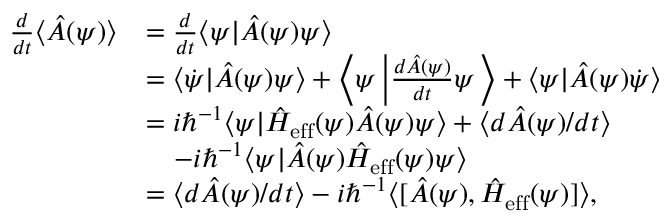<formula> <loc_0><loc_0><loc_500><loc_500>\begin{array} { r l } { \frac { d } { d t } \langle \hat { A } ( \psi ) \rangle } & { = \frac { d } { d t } \langle \psi | \hat { A } ( \psi ) \psi \rangle } \\ & { = \langle \dot { \psi } | \hat { A } ( \psi ) \psi \rangle + \left \langle \psi \left | \frac { d \hat { A } ( \psi ) } { d t } \psi \right \rangle + \langle \psi | \hat { A } ( \psi ) \dot { \psi } \rangle } \\ & { = i \hbar { ^ } { - 1 } \langle \psi | \hat { H } _ { e f f } ( \psi ) \hat { A } ( \psi ) \psi \rangle + \langle d \hat { A } ( \psi ) / d t \rangle } \\ & { - i \hbar { ^ } { - 1 } \langle \psi | \hat { A } ( \psi ) \hat { H } _ { e f f } ( \psi ) \psi \rangle } \\ & { = \langle d \hat { A } ( \psi ) / d t \rangle - i \hbar { ^ } { - 1 } \langle [ \hat { A } ( \psi ) , \hat { H } _ { e f f } ( \psi ) ] \rangle , } \end{array}</formula> 